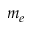Convert formula to latex. <formula><loc_0><loc_0><loc_500><loc_500>m _ { e }</formula> 